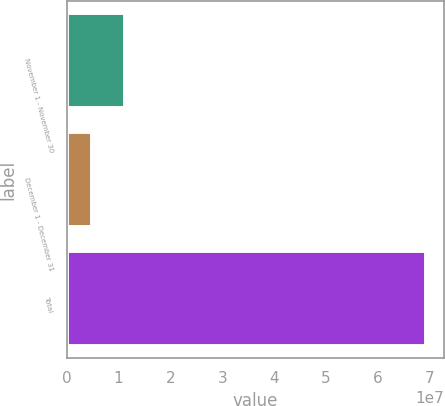<chart> <loc_0><loc_0><loc_500><loc_500><bar_chart><fcel>November 1 - November 30<fcel>December 1 - December 31<fcel>Total<nl><fcel>1.12319e+07<fcel>4.78853e+06<fcel>6.92223e+07<nl></chart> 